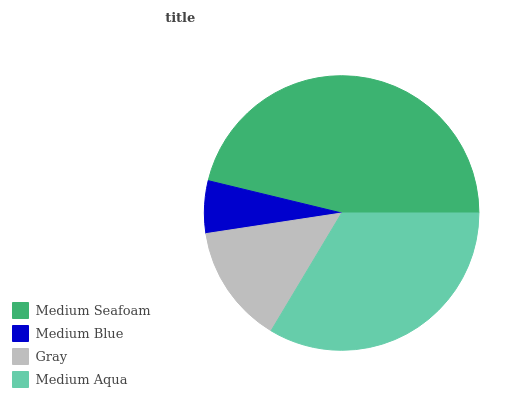Is Medium Blue the minimum?
Answer yes or no. Yes. Is Medium Seafoam the maximum?
Answer yes or no. Yes. Is Gray the minimum?
Answer yes or no. No. Is Gray the maximum?
Answer yes or no. No. Is Gray greater than Medium Blue?
Answer yes or no. Yes. Is Medium Blue less than Gray?
Answer yes or no. Yes. Is Medium Blue greater than Gray?
Answer yes or no. No. Is Gray less than Medium Blue?
Answer yes or no. No. Is Medium Aqua the high median?
Answer yes or no. Yes. Is Gray the low median?
Answer yes or no. Yes. Is Gray the high median?
Answer yes or no. No. Is Medium Aqua the low median?
Answer yes or no. No. 